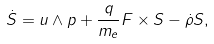Convert formula to latex. <formula><loc_0><loc_0><loc_500><loc_500>\dot { S } = u \wedge p + \frac { q } { m _ { e } } F \times S - \dot { \rho } S ,</formula> 